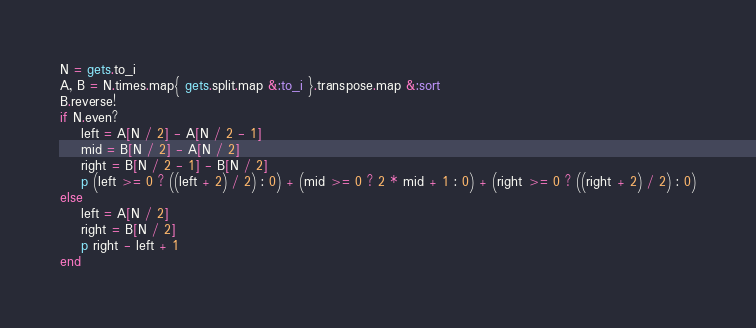<code> <loc_0><loc_0><loc_500><loc_500><_Ruby_>N = gets.to_i
A, B = N.times.map{ gets.split.map &:to_i }.transpose.map &:sort
B.reverse!
if N.even?
    left = A[N / 2] - A[N / 2 - 1]
    mid = B[N / 2] - A[N / 2]
    right = B[N / 2 - 1] - B[N / 2]
    p (left >= 0 ? ((left + 2) / 2) : 0) + (mid >= 0 ? 2 * mid + 1 : 0) + (right >= 0 ? ((right + 2) / 2) : 0)
else
    left = A[N / 2]
    right = B[N / 2]
    p right - left + 1
end</code> 